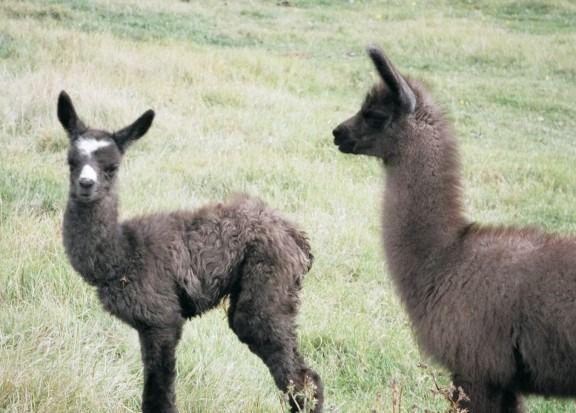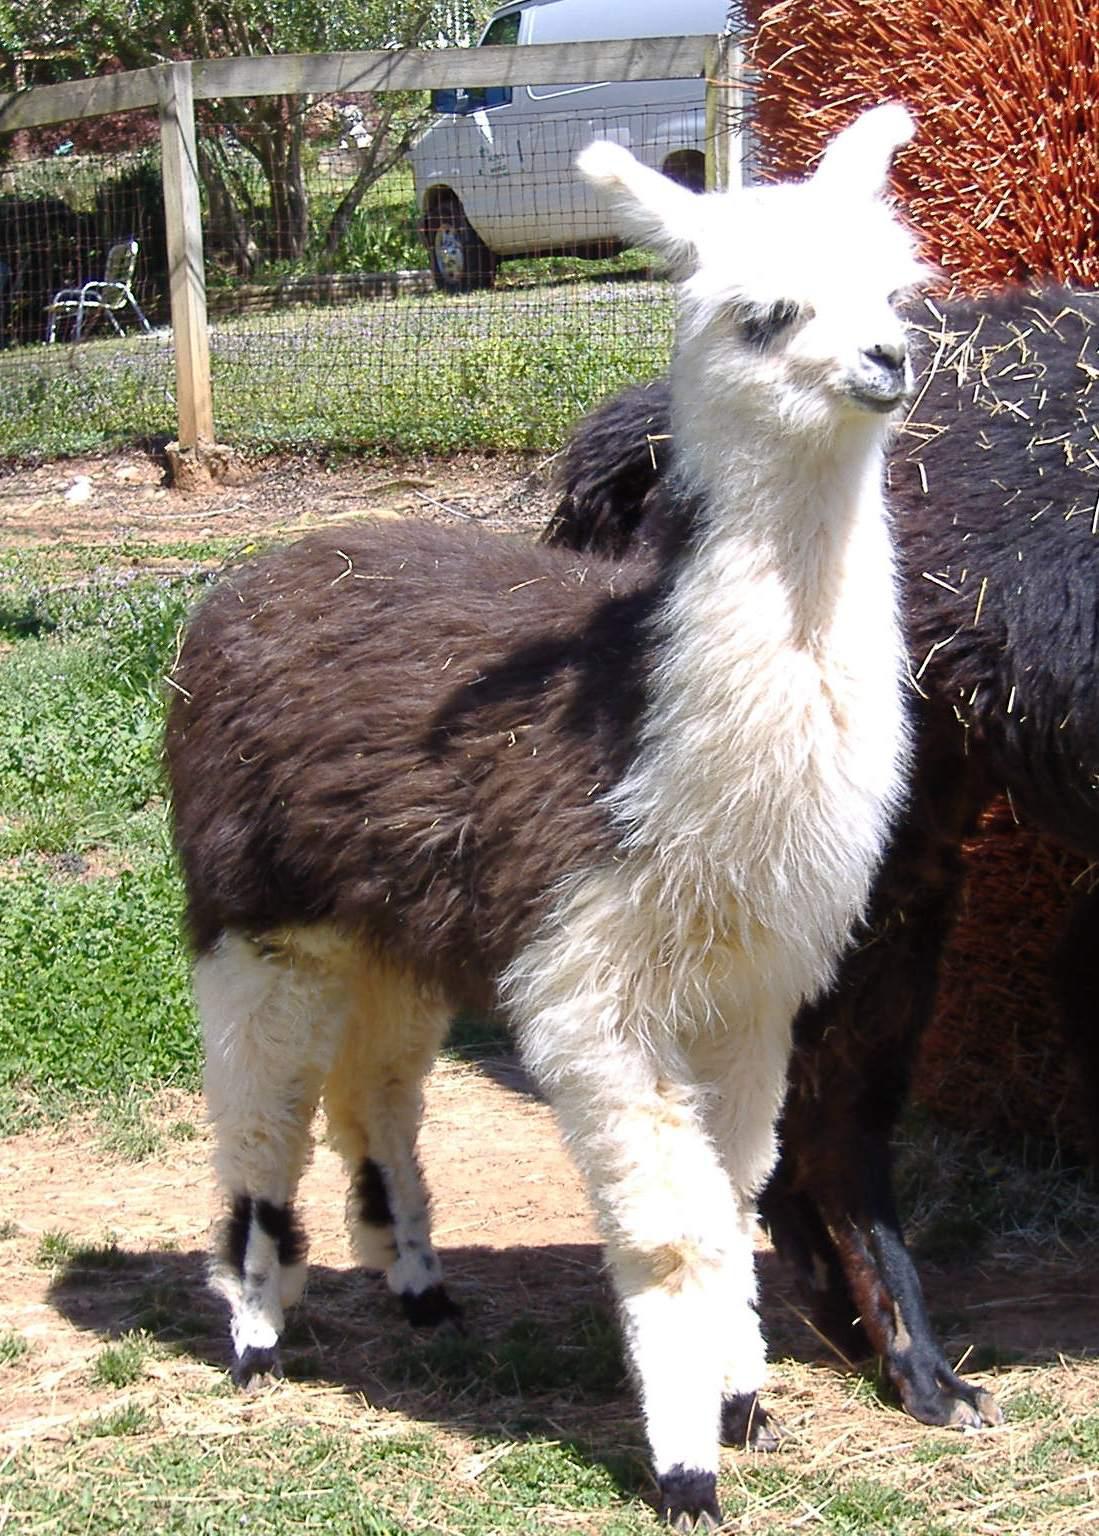The first image is the image on the left, the second image is the image on the right. Analyze the images presented: Is the assertion "In one of the images, two llamas are looking at the camera." valid? Answer yes or no. No. The first image is the image on the left, the second image is the image on the right. Examine the images to the left and right. Is the description "In at least one image there is a brown adult lama next to its black and white baby lama." accurate? Answer yes or no. No. 